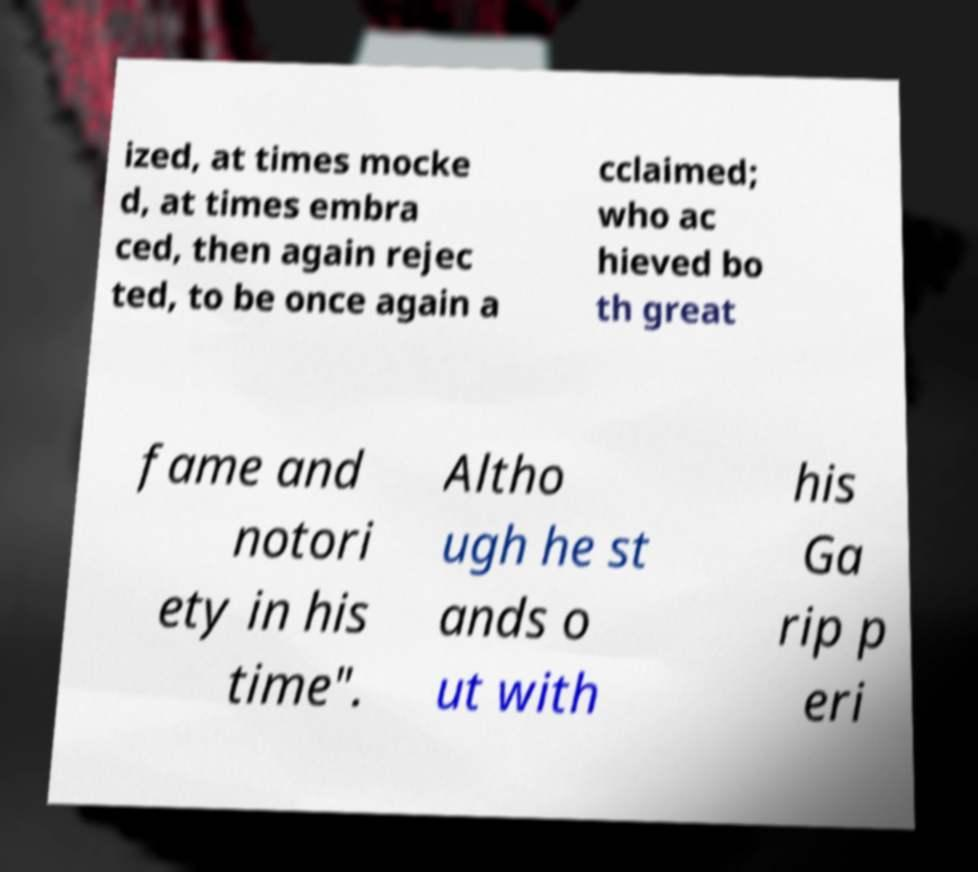Could you assist in decoding the text presented in this image and type it out clearly? ized, at times mocke d, at times embra ced, then again rejec ted, to be once again a cclaimed; who ac hieved bo th great fame and notori ety in his time". Altho ugh he st ands o ut with his Ga rip p eri 